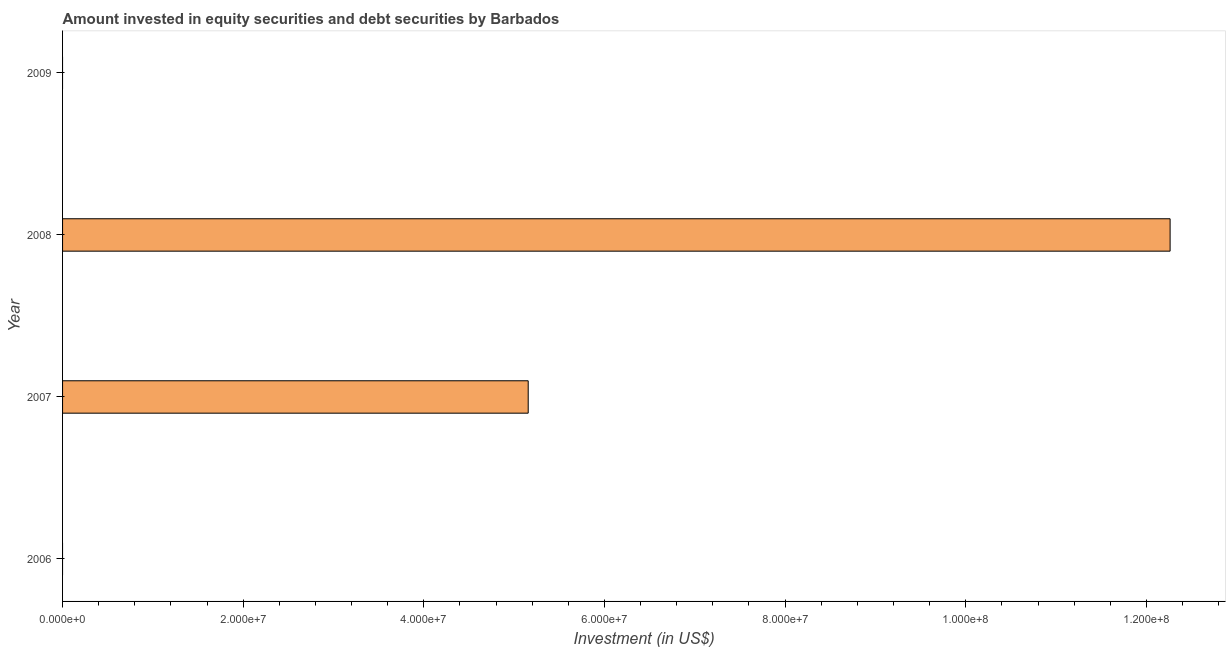Does the graph contain grids?
Give a very brief answer. No. What is the title of the graph?
Provide a short and direct response. Amount invested in equity securities and debt securities by Barbados. What is the label or title of the X-axis?
Provide a succinct answer. Investment (in US$). What is the label or title of the Y-axis?
Your answer should be very brief. Year. What is the portfolio investment in 2009?
Make the answer very short. 0. Across all years, what is the maximum portfolio investment?
Your answer should be very brief. 1.23e+08. Across all years, what is the minimum portfolio investment?
Give a very brief answer. 0. In which year was the portfolio investment maximum?
Your response must be concise. 2008. What is the sum of the portfolio investment?
Make the answer very short. 1.74e+08. What is the difference between the portfolio investment in 2007 and 2008?
Your answer should be compact. -7.11e+07. What is the average portfolio investment per year?
Give a very brief answer. 4.35e+07. What is the median portfolio investment?
Provide a short and direct response. 2.58e+07. What is the ratio of the portfolio investment in 2007 to that in 2008?
Provide a short and direct response. 0.42. Is the portfolio investment in 2007 less than that in 2008?
Provide a short and direct response. Yes. Is the sum of the portfolio investment in 2007 and 2008 greater than the maximum portfolio investment across all years?
Provide a succinct answer. Yes. What is the difference between the highest and the lowest portfolio investment?
Your answer should be compact. 1.23e+08. How many bars are there?
Give a very brief answer. 2. How many years are there in the graph?
Your answer should be very brief. 4. What is the Investment (in US$) in 2007?
Provide a short and direct response. 5.16e+07. What is the Investment (in US$) of 2008?
Ensure brevity in your answer.  1.23e+08. What is the Investment (in US$) of 2009?
Your answer should be compact. 0. What is the difference between the Investment (in US$) in 2007 and 2008?
Ensure brevity in your answer.  -7.11e+07. What is the ratio of the Investment (in US$) in 2007 to that in 2008?
Your answer should be compact. 0.42. 